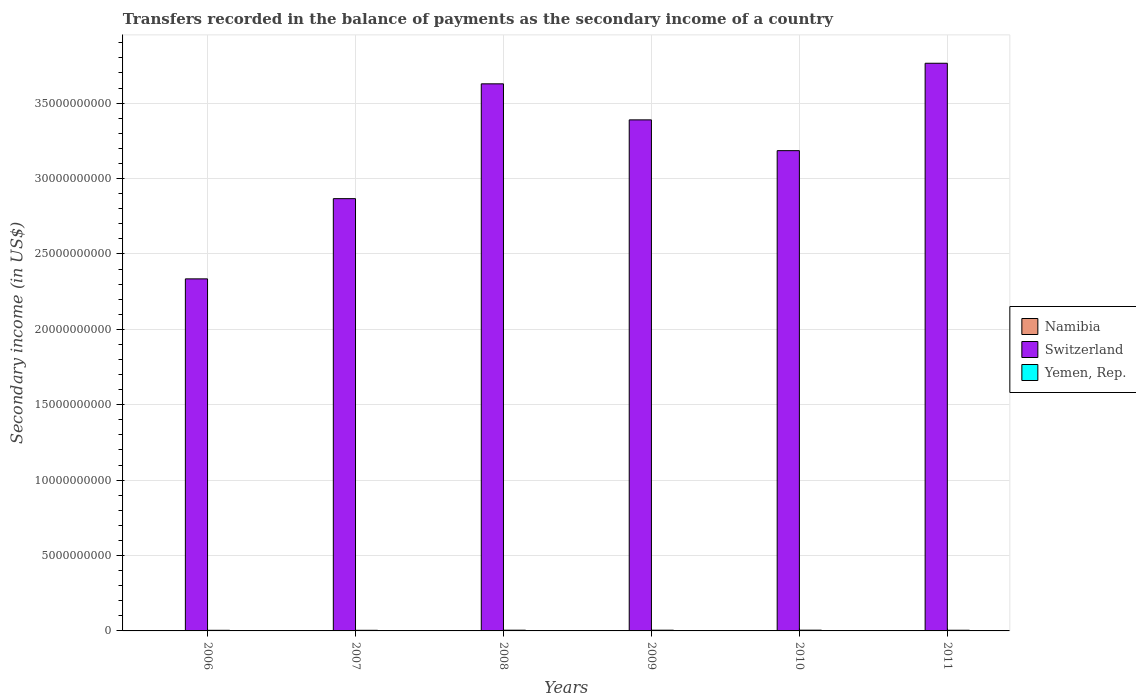How many different coloured bars are there?
Offer a terse response. 3. Are the number of bars on each tick of the X-axis equal?
Keep it short and to the point. Yes. How many bars are there on the 5th tick from the left?
Give a very brief answer. 3. In how many cases, is the number of bars for a given year not equal to the number of legend labels?
Your answer should be compact. 0. What is the secondary income of in Switzerland in 2011?
Ensure brevity in your answer.  3.76e+1. Across all years, what is the maximum secondary income of in Switzerland?
Give a very brief answer. 3.76e+1. Across all years, what is the minimum secondary income of in Yemen, Rep.?
Provide a succinct answer. 4.08e+07. In which year was the secondary income of in Namibia maximum?
Your answer should be very brief. 2006. What is the total secondary income of in Namibia in the graph?
Offer a terse response. 2.49e+07. What is the difference between the secondary income of in Yemen, Rep. in 2009 and that in 2010?
Offer a terse response. -1.48e+06. What is the difference between the secondary income of in Switzerland in 2007 and the secondary income of in Namibia in 2010?
Your response must be concise. 2.87e+1. What is the average secondary income of in Namibia per year?
Offer a very short reply. 4.16e+06. In the year 2007, what is the difference between the secondary income of in Namibia and secondary income of in Yemen, Rep.?
Your answer should be compact. -3.64e+07. What is the ratio of the secondary income of in Switzerland in 2006 to that in 2008?
Give a very brief answer. 0.64. Is the secondary income of in Namibia in 2006 less than that in 2007?
Offer a terse response. No. What is the difference between the highest and the second highest secondary income of in Switzerland?
Provide a succinct answer. 1.36e+09. What is the difference between the highest and the lowest secondary income of in Switzerland?
Provide a short and direct response. 1.43e+1. In how many years, is the secondary income of in Yemen, Rep. greater than the average secondary income of in Yemen, Rep. taken over all years?
Your answer should be very brief. 3. What does the 2nd bar from the left in 2008 represents?
Make the answer very short. Switzerland. What does the 3rd bar from the right in 2008 represents?
Keep it short and to the point. Namibia. Are all the bars in the graph horizontal?
Your answer should be compact. No. How many years are there in the graph?
Provide a succinct answer. 6. Does the graph contain grids?
Provide a succinct answer. Yes. How are the legend labels stacked?
Your response must be concise. Vertical. What is the title of the graph?
Make the answer very short. Transfers recorded in the balance of payments as the secondary income of a country. What is the label or title of the X-axis?
Your answer should be very brief. Years. What is the label or title of the Y-axis?
Your answer should be compact. Secondary income (in US$). What is the Secondary income (in US$) of Namibia in 2006?
Your answer should be very brief. 4.58e+06. What is the Secondary income (in US$) in Switzerland in 2006?
Keep it short and to the point. 2.33e+1. What is the Secondary income (in US$) in Yemen, Rep. in 2006?
Your answer should be very brief. 4.08e+07. What is the Secondary income (in US$) of Namibia in 2007?
Your answer should be very brief. 4.39e+06. What is the Secondary income (in US$) in Switzerland in 2007?
Ensure brevity in your answer.  2.87e+1. What is the Secondary income (in US$) in Yemen, Rep. in 2007?
Offer a terse response. 4.08e+07. What is the Secondary income (in US$) of Namibia in 2008?
Provide a short and direct response. 3.78e+06. What is the Secondary income (in US$) of Switzerland in 2008?
Make the answer very short. 3.63e+1. What is the Secondary income (in US$) of Yemen, Rep. in 2008?
Your answer should be very brief. 4.82e+07. What is the Secondary income (in US$) of Namibia in 2009?
Offer a very short reply. 3.69e+06. What is the Secondary income (in US$) in Switzerland in 2009?
Give a very brief answer. 3.39e+1. What is the Secondary income (in US$) in Yemen, Rep. in 2009?
Offer a very short reply. 4.82e+07. What is the Secondary income (in US$) of Namibia in 2010?
Make the answer very short. 4.22e+06. What is the Secondary income (in US$) in Switzerland in 2010?
Your answer should be compact. 3.19e+1. What is the Secondary income (in US$) in Yemen, Rep. in 2010?
Offer a terse response. 4.97e+07. What is the Secondary income (in US$) in Namibia in 2011?
Offer a very short reply. 4.27e+06. What is the Secondary income (in US$) in Switzerland in 2011?
Your response must be concise. 3.76e+1. What is the Secondary income (in US$) in Yemen, Rep. in 2011?
Offer a terse response. 4.48e+07. Across all years, what is the maximum Secondary income (in US$) in Namibia?
Offer a terse response. 4.58e+06. Across all years, what is the maximum Secondary income (in US$) of Switzerland?
Your answer should be compact. 3.76e+1. Across all years, what is the maximum Secondary income (in US$) in Yemen, Rep.?
Your response must be concise. 4.97e+07. Across all years, what is the minimum Secondary income (in US$) of Namibia?
Ensure brevity in your answer.  3.69e+06. Across all years, what is the minimum Secondary income (in US$) in Switzerland?
Offer a very short reply. 2.33e+1. Across all years, what is the minimum Secondary income (in US$) in Yemen, Rep.?
Ensure brevity in your answer.  4.08e+07. What is the total Secondary income (in US$) in Namibia in the graph?
Make the answer very short. 2.49e+07. What is the total Secondary income (in US$) of Switzerland in the graph?
Make the answer very short. 1.92e+11. What is the total Secondary income (in US$) of Yemen, Rep. in the graph?
Your answer should be very brief. 2.73e+08. What is the difference between the Secondary income (in US$) in Namibia in 2006 and that in 2007?
Your answer should be compact. 1.97e+05. What is the difference between the Secondary income (in US$) in Switzerland in 2006 and that in 2007?
Your answer should be compact. -5.32e+09. What is the difference between the Secondary income (in US$) in Namibia in 2006 and that in 2008?
Provide a short and direct response. 7.98e+05. What is the difference between the Secondary income (in US$) of Switzerland in 2006 and that in 2008?
Your response must be concise. -1.29e+1. What is the difference between the Secondary income (in US$) in Yemen, Rep. in 2006 and that in 2008?
Make the answer very short. -7.44e+06. What is the difference between the Secondary income (in US$) of Namibia in 2006 and that in 2009?
Your answer should be compact. 8.89e+05. What is the difference between the Secondary income (in US$) in Switzerland in 2006 and that in 2009?
Provide a short and direct response. -1.05e+1. What is the difference between the Secondary income (in US$) in Yemen, Rep. in 2006 and that in 2009?
Your response must be concise. -7.44e+06. What is the difference between the Secondary income (in US$) in Namibia in 2006 and that in 2010?
Your answer should be compact. 3.60e+05. What is the difference between the Secondary income (in US$) of Switzerland in 2006 and that in 2010?
Offer a terse response. -8.50e+09. What is the difference between the Secondary income (in US$) in Yemen, Rep. in 2006 and that in 2010?
Provide a succinct answer. -8.92e+06. What is the difference between the Secondary income (in US$) in Namibia in 2006 and that in 2011?
Offer a very short reply. 3.11e+05. What is the difference between the Secondary income (in US$) in Switzerland in 2006 and that in 2011?
Ensure brevity in your answer.  -1.43e+1. What is the difference between the Secondary income (in US$) in Yemen, Rep. in 2006 and that in 2011?
Offer a very short reply. -4.02e+06. What is the difference between the Secondary income (in US$) in Namibia in 2007 and that in 2008?
Give a very brief answer. 6.01e+05. What is the difference between the Secondary income (in US$) in Switzerland in 2007 and that in 2008?
Your answer should be very brief. -7.61e+09. What is the difference between the Secondary income (in US$) in Yemen, Rep. in 2007 and that in 2008?
Offer a very short reply. -7.44e+06. What is the difference between the Secondary income (in US$) of Namibia in 2007 and that in 2009?
Your answer should be very brief. 6.93e+05. What is the difference between the Secondary income (in US$) in Switzerland in 2007 and that in 2009?
Ensure brevity in your answer.  -5.22e+09. What is the difference between the Secondary income (in US$) in Yemen, Rep. in 2007 and that in 2009?
Offer a very short reply. -7.44e+06. What is the difference between the Secondary income (in US$) in Namibia in 2007 and that in 2010?
Your response must be concise. 1.63e+05. What is the difference between the Secondary income (in US$) of Switzerland in 2007 and that in 2010?
Your answer should be compact. -3.18e+09. What is the difference between the Secondary income (in US$) in Yemen, Rep. in 2007 and that in 2010?
Make the answer very short. -8.92e+06. What is the difference between the Secondary income (in US$) of Namibia in 2007 and that in 2011?
Your answer should be very brief. 1.14e+05. What is the difference between the Secondary income (in US$) of Switzerland in 2007 and that in 2011?
Make the answer very short. -8.98e+09. What is the difference between the Secondary income (in US$) in Yemen, Rep. in 2007 and that in 2011?
Give a very brief answer. -4.02e+06. What is the difference between the Secondary income (in US$) in Namibia in 2008 and that in 2009?
Offer a very short reply. 9.12e+04. What is the difference between the Secondary income (in US$) in Switzerland in 2008 and that in 2009?
Offer a terse response. 2.39e+09. What is the difference between the Secondary income (in US$) of Namibia in 2008 and that in 2010?
Your response must be concise. -4.39e+05. What is the difference between the Secondary income (in US$) in Switzerland in 2008 and that in 2010?
Make the answer very short. 4.43e+09. What is the difference between the Secondary income (in US$) of Yemen, Rep. in 2008 and that in 2010?
Offer a very short reply. -1.48e+06. What is the difference between the Secondary income (in US$) of Namibia in 2008 and that in 2011?
Offer a very short reply. -4.87e+05. What is the difference between the Secondary income (in US$) of Switzerland in 2008 and that in 2011?
Ensure brevity in your answer.  -1.36e+09. What is the difference between the Secondary income (in US$) in Yemen, Rep. in 2008 and that in 2011?
Offer a very short reply. 3.42e+06. What is the difference between the Secondary income (in US$) in Namibia in 2009 and that in 2010?
Make the answer very short. -5.30e+05. What is the difference between the Secondary income (in US$) of Switzerland in 2009 and that in 2010?
Make the answer very short. 2.04e+09. What is the difference between the Secondary income (in US$) in Yemen, Rep. in 2009 and that in 2010?
Ensure brevity in your answer.  -1.48e+06. What is the difference between the Secondary income (in US$) in Namibia in 2009 and that in 2011?
Give a very brief answer. -5.78e+05. What is the difference between the Secondary income (in US$) in Switzerland in 2009 and that in 2011?
Your answer should be very brief. -3.75e+09. What is the difference between the Secondary income (in US$) of Yemen, Rep. in 2009 and that in 2011?
Offer a terse response. 3.42e+06. What is the difference between the Secondary income (in US$) in Namibia in 2010 and that in 2011?
Make the answer very short. -4.85e+04. What is the difference between the Secondary income (in US$) in Switzerland in 2010 and that in 2011?
Keep it short and to the point. -5.80e+09. What is the difference between the Secondary income (in US$) of Yemen, Rep. in 2010 and that in 2011?
Offer a very short reply. 4.90e+06. What is the difference between the Secondary income (in US$) in Namibia in 2006 and the Secondary income (in US$) in Switzerland in 2007?
Your response must be concise. -2.87e+1. What is the difference between the Secondary income (in US$) in Namibia in 2006 and the Secondary income (in US$) in Yemen, Rep. in 2007?
Your response must be concise. -3.62e+07. What is the difference between the Secondary income (in US$) of Switzerland in 2006 and the Secondary income (in US$) of Yemen, Rep. in 2007?
Keep it short and to the point. 2.33e+1. What is the difference between the Secondary income (in US$) in Namibia in 2006 and the Secondary income (in US$) in Switzerland in 2008?
Your answer should be very brief. -3.63e+1. What is the difference between the Secondary income (in US$) in Namibia in 2006 and the Secondary income (in US$) in Yemen, Rep. in 2008?
Your answer should be very brief. -4.37e+07. What is the difference between the Secondary income (in US$) in Switzerland in 2006 and the Secondary income (in US$) in Yemen, Rep. in 2008?
Provide a succinct answer. 2.33e+1. What is the difference between the Secondary income (in US$) of Namibia in 2006 and the Secondary income (in US$) of Switzerland in 2009?
Ensure brevity in your answer.  -3.39e+1. What is the difference between the Secondary income (in US$) of Namibia in 2006 and the Secondary income (in US$) of Yemen, Rep. in 2009?
Offer a terse response. -4.37e+07. What is the difference between the Secondary income (in US$) in Switzerland in 2006 and the Secondary income (in US$) in Yemen, Rep. in 2009?
Ensure brevity in your answer.  2.33e+1. What is the difference between the Secondary income (in US$) in Namibia in 2006 and the Secondary income (in US$) in Switzerland in 2010?
Provide a short and direct response. -3.18e+1. What is the difference between the Secondary income (in US$) of Namibia in 2006 and the Secondary income (in US$) of Yemen, Rep. in 2010?
Give a very brief answer. -4.51e+07. What is the difference between the Secondary income (in US$) in Switzerland in 2006 and the Secondary income (in US$) in Yemen, Rep. in 2010?
Your answer should be very brief. 2.33e+1. What is the difference between the Secondary income (in US$) in Namibia in 2006 and the Secondary income (in US$) in Switzerland in 2011?
Provide a short and direct response. -3.76e+1. What is the difference between the Secondary income (in US$) in Namibia in 2006 and the Secondary income (in US$) in Yemen, Rep. in 2011?
Offer a terse response. -4.02e+07. What is the difference between the Secondary income (in US$) of Switzerland in 2006 and the Secondary income (in US$) of Yemen, Rep. in 2011?
Offer a terse response. 2.33e+1. What is the difference between the Secondary income (in US$) of Namibia in 2007 and the Secondary income (in US$) of Switzerland in 2008?
Offer a very short reply. -3.63e+1. What is the difference between the Secondary income (in US$) of Namibia in 2007 and the Secondary income (in US$) of Yemen, Rep. in 2008?
Make the answer very short. -4.39e+07. What is the difference between the Secondary income (in US$) in Switzerland in 2007 and the Secondary income (in US$) in Yemen, Rep. in 2008?
Provide a succinct answer. 2.86e+1. What is the difference between the Secondary income (in US$) in Namibia in 2007 and the Secondary income (in US$) in Switzerland in 2009?
Give a very brief answer. -3.39e+1. What is the difference between the Secondary income (in US$) of Namibia in 2007 and the Secondary income (in US$) of Yemen, Rep. in 2009?
Offer a very short reply. -4.39e+07. What is the difference between the Secondary income (in US$) in Switzerland in 2007 and the Secondary income (in US$) in Yemen, Rep. in 2009?
Provide a short and direct response. 2.86e+1. What is the difference between the Secondary income (in US$) of Namibia in 2007 and the Secondary income (in US$) of Switzerland in 2010?
Provide a short and direct response. -3.18e+1. What is the difference between the Secondary income (in US$) in Namibia in 2007 and the Secondary income (in US$) in Yemen, Rep. in 2010?
Provide a short and direct response. -4.53e+07. What is the difference between the Secondary income (in US$) of Switzerland in 2007 and the Secondary income (in US$) of Yemen, Rep. in 2010?
Your answer should be very brief. 2.86e+1. What is the difference between the Secondary income (in US$) of Namibia in 2007 and the Secondary income (in US$) of Switzerland in 2011?
Offer a very short reply. -3.76e+1. What is the difference between the Secondary income (in US$) of Namibia in 2007 and the Secondary income (in US$) of Yemen, Rep. in 2011?
Ensure brevity in your answer.  -4.04e+07. What is the difference between the Secondary income (in US$) of Switzerland in 2007 and the Secondary income (in US$) of Yemen, Rep. in 2011?
Offer a terse response. 2.86e+1. What is the difference between the Secondary income (in US$) in Namibia in 2008 and the Secondary income (in US$) in Switzerland in 2009?
Your answer should be very brief. -3.39e+1. What is the difference between the Secondary income (in US$) of Namibia in 2008 and the Secondary income (in US$) of Yemen, Rep. in 2009?
Give a very brief answer. -4.45e+07. What is the difference between the Secondary income (in US$) in Switzerland in 2008 and the Secondary income (in US$) in Yemen, Rep. in 2009?
Your response must be concise. 3.62e+1. What is the difference between the Secondary income (in US$) in Namibia in 2008 and the Secondary income (in US$) in Switzerland in 2010?
Offer a very short reply. -3.18e+1. What is the difference between the Secondary income (in US$) in Namibia in 2008 and the Secondary income (in US$) in Yemen, Rep. in 2010?
Keep it short and to the point. -4.59e+07. What is the difference between the Secondary income (in US$) of Switzerland in 2008 and the Secondary income (in US$) of Yemen, Rep. in 2010?
Make the answer very short. 3.62e+1. What is the difference between the Secondary income (in US$) in Namibia in 2008 and the Secondary income (in US$) in Switzerland in 2011?
Offer a very short reply. -3.76e+1. What is the difference between the Secondary income (in US$) in Namibia in 2008 and the Secondary income (in US$) in Yemen, Rep. in 2011?
Ensure brevity in your answer.  -4.10e+07. What is the difference between the Secondary income (in US$) in Switzerland in 2008 and the Secondary income (in US$) in Yemen, Rep. in 2011?
Give a very brief answer. 3.62e+1. What is the difference between the Secondary income (in US$) of Namibia in 2009 and the Secondary income (in US$) of Switzerland in 2010?
Make the answer very short. -3.18e+1. What is the difference between the Secondary income (in US$) of Namibia in 2009 and the Secondary income (in US$) of Yemen, Rep. in 2010?
Keep it short and to the point. -4.60e+07. What is the difference between the Secondary income (in US$) of Switzerland in 2009 and the Secondary income (in US$) of Yemen, Rep. in 2010?
Give a very brief answer. 3.38e+1. What is the difference between the Secondary income (in US$) of Namibia in 2009 and the Secondary income (in US$) of Switzerland in 2011?
Your response must be concise. -3.76e+1. What is the difference between the Secondary income (in US$) of Namibia in 2009 and the Secondary income (in US$) of Yemen, Rep. in 2011?
Offer a very short reply. -4.11e+07. What is the difference between the Secondary income (in US$) in Switzerland in 2009 and the Secondary income (in US$) in Yemen, Rep. in 2011?
Offer a terse response. 3.38e+1. What is the difference between the Secondary income (in US$) in Namibia in 2010 and the Secondary income (in US$) in Switzerland in 2011?
Provide a succinct answer. -3.76e+1. What is the difference between the Secondary income (in US$) of Namibia in 2010 and the Secondary income (in US$) of Yemen, Rep. in 2011?
Offer a terse response. -4.06e+07. What is the difference between the Secondary income (in US$) of Switzerland in 2010 and the Secondary income (in US$) of Yemen, Rep. in 2011?
Offer a terse response. 3.18e+1. What is the average Secondary income (in US$) of Namibia per year?
Keep it short and to the point. 4.16e+06. What is the average Secondary income (in US$) of Switzerland per year?
Your answer should be very brief. 3.19e+1. What is the average Secondary income (in US$) in Yemen, Rep. per year?
Your answer should be very brief. 4.54e+07. In the year 2006, what is the difference between the Secondary income (in US$) in Namibia and Secondary income (in US$) in Switzerland?
Your answer should be compact. -2.33e+1. In the year 2006, what is the difference between the Secondary income (in US$) of Namibia and Secondary income (in US$) of Yemen, Rep.?
Your answer should be very brief. -3.62e+07. In the year 2006, what is the difference between the Secondary income (in US$) of Switzerland and Secondary income (in US$) of Yemen, Rep.?
Provide a succinct answer. 2.33e+1. In the year 2007, what is the difference between the Secondary income (in US$) of Namibia and Secondary income (in US$) of Switzerland?
Provide a succinct answer. -2.87e+1. In the year 2007, what is the difference between the Secondary income (in US$) of Namibia and Secondary income (in US$) of Yemen, Rep.?
Your answer should be compact. -3.64e+07. In the year 2007, what is the difference between the Secondary income (in US$) of Switzerland and Secondary income (in US$) of Yemen, Rep.?
Offer a terse response. 2.86e+1. In the year 2008, what is the difference between the Secondary income (in US$) of Namibia and Secondary income (in US$) of Switzerland?
Make the answer very short. -3.63e+1. In the year 2008, what is the difference between the Secondary income (in US$) in Namibia and Secondary income (in US$) in Yemen, Rep.?
Your answer should be compact. -4.45e+07. In the year 2008, what is the difference between the Secondary income (in US$) in Switzerland and Secondary income (in US$) in Yemen, Rep.?
Provide a succinct answer. 3.62e+1. In the year 2009, what is the difference between the Secondary income (in US$) of Namibia and Secondary income (in US$) of Switzerland?
Provide a short and direct response. -3.39e+1. In the year 2009, what is the difference between the Secondary income (in US$) in Namibia and Secondary income (in US$) in Yemen, Rep.?
Provide a short and direct response. -4.45e+07. In the year 2009, what is the difference between the Secondary income (in US$) in Switzerland and Secondary income (in US$) in Yemen, Rep.?
Provide a short and direct response. 3.38e+1. In the year 2010, what is the difference between the Secondary income (in US$) in Namibia and Secondary income (in US$) in Switzerland?
Give a very brief answer. -3.18e+1. In the year 2010, what is the difference between the Secondary income (in US$) of Namibia and Secondary income (in US$) of Yemen, Rep.?
Keep it short and to the point. -4.55e+07. In the year 2010, what is the difference between the Secondary income (in US$) in Switzerland and Secondary income (in US$) in Yemen, Rep.?
Your response must be concise. 3.18e+1. In the year 2011, what is the difference between the Secondary income (in US$) of Namibia and Secondary income (in US$) of Switzerland?
Offer a very short reply. -3.76e+1. In the year 2011, what is the difference between the Secondary income (in US$) in Namibia and Secondary income (in US$) in Yemen, Rep.?
Keep it short and to the point. -4.05e+07. In the year 2011, what is the difference between the Secondary income (in US$) of Switzerland and Secondary income (in US$) of Yemen, Rep.?
Offer a very short reply. 3.76e+1. What is the ratio of the Secondary income (in US$) in Namibia in 2006 to that in 2007?
Keep it short and to the point. 1.04. What is the ratio of the Secondary income (in US$) of Switzerland in 2006 to that in 2007?
Ensure brevity in your answer.  0.81. What is the ratio of the Secondary income (in US$) in Yemen, Rep. in 2006 to that in 2007?
Ensure brevity in your answer.  1. What is the ratio of the Secondary income (in US$) in Namibia in 2006 to that in 2008?
Provide a short and direct response. 1.21. What is the ratio of the Secondary income (in US$) of Switzerland in 2006 to that in 2008?
Offer a very short reply. 0.64. What is the ratio of the Secondary income (in US$) of Yemen, Rep. in 2006 to that in 2008?
Your answer should be very brief. 0.85. What is the ratio of the Secondary income (in US$) of Namibia in 2006 to that in 2009?
Provide a short and direct response. 1.24. What is the ratio of the Secondary income (in US$) of Switzerland in 2006 to that in 2009?
Your response must be concise. 0.69. What is the ratio of the Secondary income (in US$) in Yemen, Rep. in 2006 to that in 2009?
Give a very brief answer. 0.85. What is the ratio of the Secondary income (in US$) of Namibia in 2006 to that in 2010?
Make the answer very short. 1.09. What is the ratio of the Secondary income (in US$) of Switzerland in 2006 to that in 2010?
Make the answer very short. 0.73. What is the ratio of the Secondary income (in US$) in Yemen, Rep. in 2006 to that in 2010?
Keep it short and to the point. 0.82. What is the ratio of the Secondary income (in US$) in Namibia in 2006 to that in 2011?
Ensure brevity in your answer.  1.07. What is the ratio of the Secondary income (in US$) of Switzerland in 2006 to that in 2011?
Give a very brief answer. 0.62. What is the ratio of the Secondary income (in US$) in Yemen, Rep. in 2006 to that in 2011?
Keep it short and to the point. 0.91. What is the ratio of the Secondary income (in US$) of Namibia in 2007 to that in 2008?
Your answer should be compact. 1.16. What is the ratio of the Secondary income (in US$) of Switzerland in 2007 to that in 2008?
Make the answer very short. 0.79. What is the ratio of the Secondary income (in US$) in Yemen, Rep. in 2007 to that in 2008?
Offer a terse response. 0.85. What is the ratio of the Secondary income (in US$) in Namibia in 2007 to that in 2009?
Offer a terse response. 1.19. What is the ratio of the Secondary income (in US$) of Switzerland in 2007 to that in 2009?
Make the answer very short. 0.85. What is the ratio of the Secondary income (in US$) in Yemen, Rep. in 2007 to that in 2009?
Ensure brevity in your answer.  0.85. What is the ratio of the Secondary income (in US$) in Namibia in 2007 to that in 2010?
Provide a short and direct response. 1.04. What is the ratio of the Secondary income (in US$) in Yemen, Rep. in 2007 to that in 2010?
Provide a short and direct response. 0.82. What is the ratio of the Secondary income (in US$) of Namibia in 2007 to that in 2011?
Your response must be concise. 1.03. What is the ratio of the Secondary income (in US$) in Switzerland in 2007 to that in 2011?
Make the answer very short. 0.76. What is the ratio of the Secondary income (in US$) of Yemen, Rep. in 2007 to that in 2011?
Your answer should be compact. 0.91. What is the ratio of the Secondary income (in US$) of Namibia in 2008 to that in 2009?
Ensure brevity in your answer.  1.02. What is the ratio of the Secondary income (in US$) in Switzerland in 2008 to that in 2009?
Offer a very short reply. 1.07. What is the ratio of the Secondary income (in US$) in Yemen, Rep. in 2008 to that in 2009?
Offer a terse response. 1. What is the ratio of the Secondary income (in US$) of Namibia in 2008 to that in 2010?
Your answer should be compact. 0.9. What is the ratio of the Secondary income (in US$) of Switzerland in 2008 to that in 2010?
Your response must be concise. 1.14. What is the ratio of the Secondary income (in US$) of Yemen, Rep. in 2008 to that in 2010?
Offer a terse response. 0.97. What is the ratio of the Secondary income (in US$) of Namibia in 2008 to that in 2011?
Give a very brief answer. 0.89. What is the ratio of the Secondary income (in US$) of Switzerland in 2008 to that in 2011?
Provide a short and direct response. 0.96. What is the ratio of the Secondary income (in US$) of Yemen, Rep. in 2008 to that in 2011?
Your answer should be compact. 1.08. What is the ratio of the Secondary income (in US$) of Namibia in 2009 to that in 2010?
Your answer should be very brief. 0.87. What is the ratio of the Secondary income (in US$) in Switzerland in 2009 to that in 2010?
Ensure brevity in your answer.  1.06. What is the ratio of the Secondary income (in US$) of Yemen, Rep. in 2009 to that in 2010?
Your response must be concise. 0.97. What is the ratio of the Secondary income (in US$) in Namibia in 2009 to that in 2011?
Your response must be concise. 0.86. What is the ratio of the Secondary income (in US$) of Switzerland in 2009 to that in 2011?
Make the answer very short. 0.9. What is the ratio of the Secondary income (in US$) in Yemen, Rep. in 2009 to that in 2011?
Ensure brevity in your answer.  1.08. What is the ratio of the Secondary income (in US$) of Namibia in 2010 to that in 2011?
Ensure brevity in your answer.  0.99. What is the ratio of the Secondary income (in US$) of Switzerland in 2010 to that in 2011?
Provide a short and direct response. 0.85. What is the ratio of the Secondary income (in US$) of Yemen, Rep. in 2010 to that in 2011?
Ensure brevity in your answer.  1.11. What is the difference between the highest and the second highest Secondary income (in US$) in Namibia?
Your answer should be very brief. 1.97e+05. What is the difference between the highest and the second highest Secondary income (in US$) of Switzerland?
Offer a terse response. 1.36e+09. What is the difference between the highest and the second highest Secondary income (in US$) of Yemen, Rep.?
Provide a short and direct response. 1.48e+06. What is the difference between the highest and the lowest Secondary income (in US$) of Namibia?
Give a very brief answer. 8.89e+05. What is the difference between the highest and the lowest Secondary income (in US$) of Switzerland?
Your answer should be very brief. 1.43e+1. What is the difference between the highest and the lowest Secondary income (in US$) in Yemen, Rep.?
Ensure brevity in your answer.  8.92e+06. 